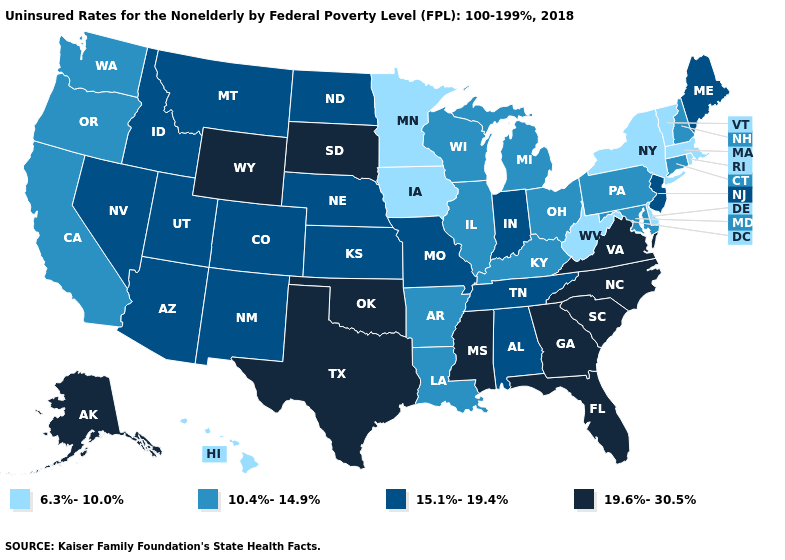Does the first symbol in the legend represent the smallest category?
Keep it brief. Yes. Which states have the lowest value in the USA?
Quick response, please. Delaware, Hawaii, Iowa, Massachusetts, Minnesota, New York, Rhode Island, Vermont, West Virginia. Name the states that have a value in the range 10.4%-14.9%?
Be succinct. Arkansas, California, Connecticut, Illinois, Kentucky, Louisiana, Maryland, Michigan, New Hampshire, Ohio, Oregon, Pennsylvania, Washington, Wisconsin. What is the lowest value in the MidWest?
Be succinct. 6.3%-10.0%. What is the highest value in the Northeast ?
Short answer required. 15.1%-19.4%. Name the states that have a value in the range 6.3%-10.0%?
Answer briefly. Delaware, Hawaii, Iowa, Massachusetts, Minnesota, New York, Rhode Island, Vermont, West Virginia. Among the states that border Indiana , which have the highest value?
Concise answer only. Illinois, Kentucky, Michigan, Ohio. What is the highest value in states that border Vermont?
Give a very brief answer. 10.4%-14.9%. Name the states that have a value in the range 6.3%-10.0%?
Quick response, please. Delaware, Hawaii, Iowa, Massachusetts, Minnesota, New York, Rhode Island, Vermont, West Virginia. Does the map have missing data?
Give a very brief answer. No. What is the value of West Virginia?
Be succinct. 6.3%-10.0%. Among the states that border Vermont , does New York have the lowest value?
Quick response, please. Yes. Does Mississippi have the lowest value in the USA?
Give a very brief answer. No. Does the first symbol in the legend represent the smallest category?
Quick response, please. Yes. 